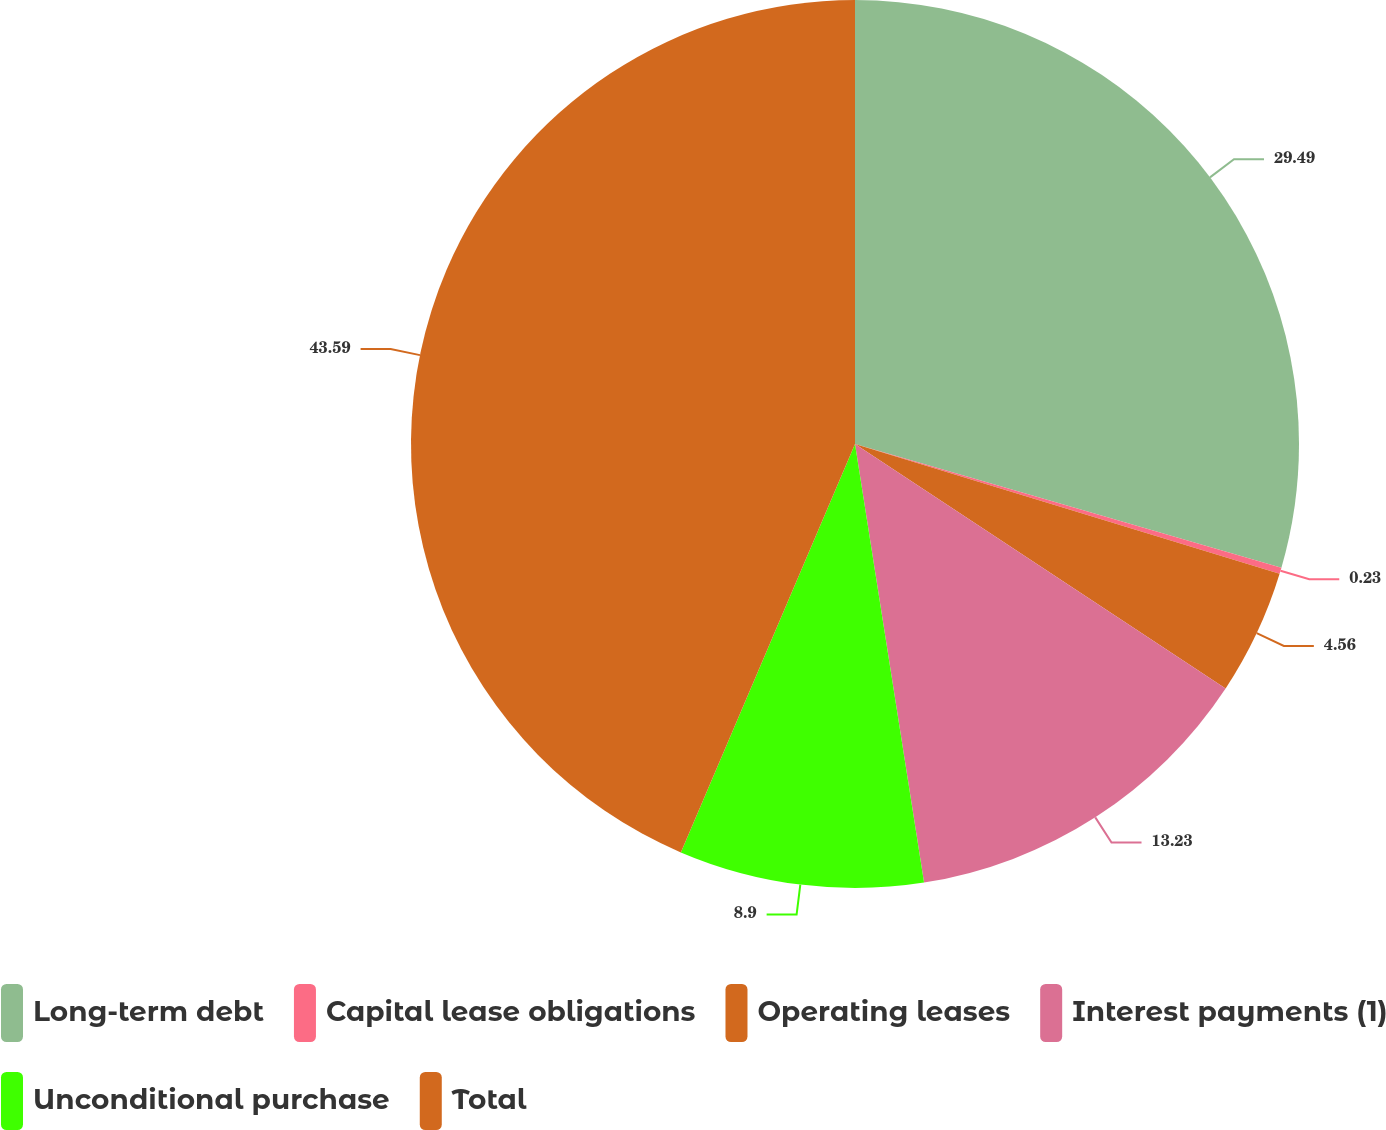Convert chart to OTSL. <chart><loc_0><loc_0><loc_500><loc_500><pie_chart><fcel>Long-term debt<fcel>Capital lease obligations<fcel>Operating leases<fcel>Interest payments (1)<fcel>Unconditional purchase<fcel>Total<nl><fcel>29.49%<fcel>0.23%<fcel>4.56%<fcel>13.23%<fcel>8.9%<fcel>43.58%<nl></chart> 